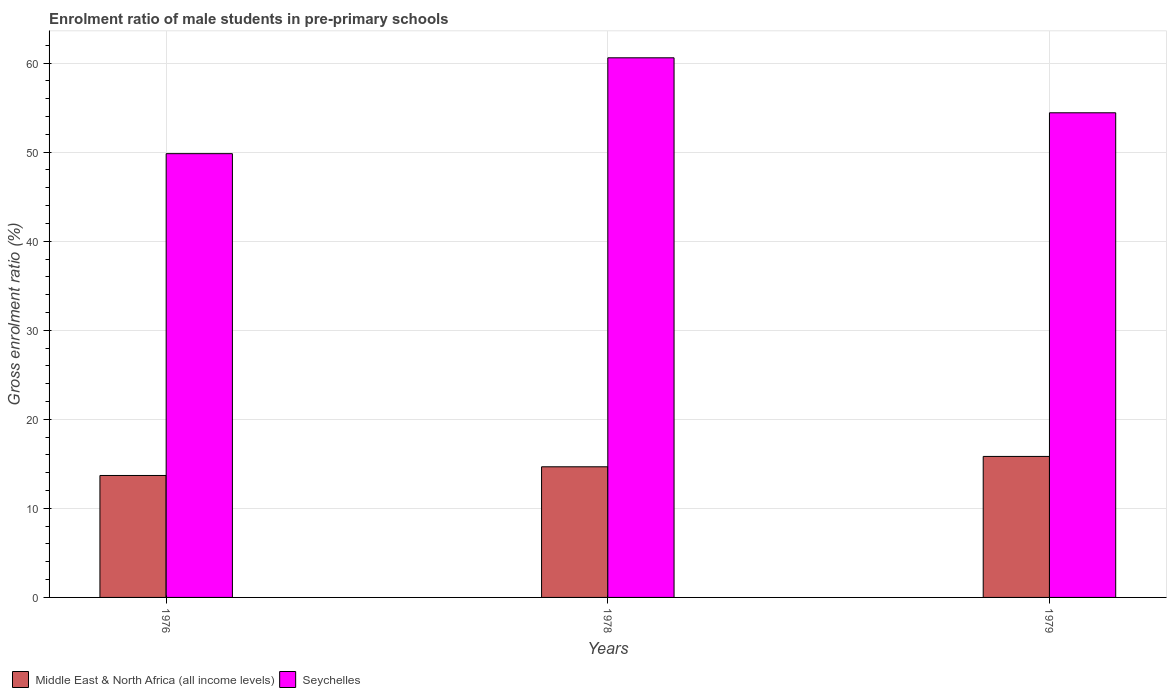How many groups of bars are there?
Your response must be concise. 3. Are the number of bars on each tick of the X-axis equal?
Keep it short and to the point. Yes. What is the label of the 2nd group of bars from the left?
Provide a succinct answer. 1978. In how many cases, is the number of bars for a given year not equal to the number of legend labels?
Your response must be concise. 0. What is the enrolment ratio of male students in pre-primary schools in Middle East & North Africa (all income levels) in 1978?
Offer a terse response. 14.67. Across all years, what is the maximum enrolment ratio of male students in pre-primary schools in Seychelles?
Your response must be concise. 60.59. Across all years, what is the minimum enrolment ratio of male students in pre-primary schools in Middle East & North Africa (all income levels)?
Offer a very short reply. 13.69. In which year was the enrolment ratio of male students in pre-primary schools in Middle East & North Africa (all income levels) maximum?
Make the answer very short. 1979. In which year was the enrolment ratio of male students in pre-primary schools in Seychelles minimum?
Offer a very short reply. 1976. What is the total enrolment ratio of male students in pre-primary schools in Seychelles in the graph?
Provide a succinct answer. 164.84. What is the difference between the enrolment ratio of male students in pre-primary schools in Seychelles in 1976 and that in 1978?
Keep it short and to the point. -10.76. What is the difference between the enrolment ratio of male students in pre-primary schools in Seychelles in 1976 and the enrolment ratio of male students in pre-primary schools in Middle East & North Africa (all income levels) in 1978?
Offer a terse response. 35.16. What is the average enrolment ratio of male students in pre-primary schools in Seychelles per year?
Your answer should be compact. 54.95. In the year 1978, what is the difference between the enrolment ratio of male students in pre-primary schools in Seychelles and enrolment ratio of male students in pre-primary schools in Middle East & North Africa (all income levels)?
Provide a succinct answer. 45.92. What is the ratio of the enrolment ratio of male students in pre-primary schools in Middle East & North Africa (all income levels) in 1978 to that in 1979?
Make the answer very short. 0.93. Is the enrolment ratio of male students in pre-primary schools in Middle East & North Africa (all income levels) in 1976 less than that in 1978?
Make the answer very short. Yes. What is the difference between the highest and the second highest enrolment ratio of male students in pre-primary schools in Middle East & North Africa (all income levels)?
Provide a succinct answer. 1.16. What is the difference between the highest and the lowest enrolment ratio of male students in pre-primary schools in Middle East & North Africa (all income levels)?
Offer a terse response. 2.14. Is the sum of the enrolment ratio of male students in pre-primary schools in Middle East & North Africa (all income levels) in 1978 and 1979 greater than the maximum enrolment ratio of male students in pre-primary schools in Seychelles across all years?
Make the answer very short. No. What does the 2nd bar from the left in 1978 represents?
Offer a terse response. Seychelles. What does the 2nd bar from the right in 1978 represents?
Provide a succinct answer. Middle East & North Africa (all income levels). Does the graph contain any zero values?
Keep it short and to the point. No. Does the graph contain grids?
Your answer should be very brief. Yes. Where does the legend appear in the graph?
Ensure brevity in your answer.  Bottom left. How many legend labels are there?
Provide a short and direct response. 2. How are the legend labels stacked?
Your answer should be compact. Horizontal. What is the title of the graph?
Your response must be concise. Enrolment ratio of male students in pre-primary schools. What is the label or title of the Y-axis?
Provide a succinct answer. Gross enrolment ratio (%). What is the Gross enrolment ratio (%) in Middle East & North Africa (all income levels) in 1976?
Ensure brevity in your answer.  13.69. What is the Gross enrolment ratio (%) in Seychelles in 1976?
Give a very brief answer. 49.83. What is the Gross enrolment ratio (%) of Middle East & North Africa (all income levels) in 1978?
Your response must be concise. 14.67. What is the Gross enrolment ratio (%) of Seychelles in 1978?
Keep it short and to the point. 60.59. What is the Gross enrolment ratio (%) of Middle East & North Africa (all income levels) in 1979?
Keep it short and to the point. 15.83. What is the Gross enrolment ratio (%) of Seychelles in 1979?
Provide a short and direct response. 54.42. Across all years, what is the maximum Gross enrolment ratio (%) in Middle East & North Africa (all income levels)?
Give a very brief answer. 15.83. Across all years, what is the maximum Gross enrolment ratio (%) of Seychelles?
Your response must be concise. 60.59. Across all years, what is the minimum Gross enrolment ratio (%) in Middle East & North Africa (all income levels)?
Provide a succinct answer. 13.69. Across all years, what is the minimum Gross enrolment ratio (%) of Seychelles?
Make the answer very short. 49.83. What is the total Gross enrolment ratio (%) in Middle East & North Africa (all income levels) in the graph?
Your answer should be compact. 44.19. What is the total Gross enrolment ratio (%) in Seychelles in the graph?
Ensure brevity in your answer.  164.84. What is the difference between the Gross enrolment ratio (%) in Middle East & North Africa (all income levels) in 1976 and that in 1978?
Your answer should be very brief. -0.97. What is the difference between the Gross enrolment ratio (%) in Seychelles in 1976 and that in 1978?
Provide a short and direct response. -10.76. What is the difference between the Gross enrolment ratio (%) of Middle East & North Africa (all income levels) in 1976 and that in 1979?
Make the answer very short. -2.14. What is the difference between the Gross enrolment ratio (%) in Seychelles in 1976 and that in 1979?
Provide a short and direct response. -4.59. What is the difference between the Gross enrolment ratio (%) of Middle East & North Africa (all income levels) in 1978 and that in 1979?
Give a very brief answer. -1.16. What is the difference between the Gross enrolment ratio (%) of Seychelles in 1978 and that in 1979?
Keep it short and to the point. 6.17. What is the difference between the Gross enrolment ratio (%) of Middle East & North Africa (all income levels) in 1976 and the Gross enrolment ratio (%) of Seychelles in 1978?
Your answer should be very brief. -46.9. What is the difference between the Gross enrolment ratio (%) in Middle East & North Africa (all income levels) in 1976 and the Gross enrolment ratio (%) in Seychelles in 1979?
Provide a short and direct response. -40.73. What is the difference between the Gross enrolment ratio (%) in Middle East & North Africa (all income levels) in 1978 and the Gross enrolment ratio (%) in Seychelles in 1979?
Your response must be concise. -39.75. What is the average Gross enrolment ratio (%) of Middle East & North Africa (all income levels) per year?
Ensure brevity in your answer.  14.73. What is the average Gross enrolment ratio (%) of Seychelles per year?
Your answer should be compact. 54.95. In the year 1976, what is the difference between the Gross enrolment ratio (%) in Middle East & North Africa (all income levels) and Gross enrolment ratio (%) in Seychelles?
Keep it short and to the point. -36.14. In the year 1978, what is the difference between the Gross enrolment ratio (%) in Middle East & North Africa (all income levels) and Gross enrolment ratio (%) in Seychelles?
Offer a terse response. -45.92. In the year 1979, what is the difference between the Gross enrolment ratio (%) of Middle East & North Africa (all income levels) and Gross enrolment ratio (%) of Seychelles?
Your answer should be very brief. -38.59. What is the ratio of the Gross enrolment ratio (%) in Middle East & North Africa (all income levels) in 1976 to that in 1978?
Ensure brevity in your answer.  0.93. What is the ratio of the Gross enrolment ratio (%) of Seychelles in 1976 to that in 1978?
Make the answer very short. 0.82. What is the ratio of the Gross enrolment ratio (%) of Middle East & North Africa (all income levels) in 1976 to that in 1979?
Give a very brief answer. 0.86. What is the ratio of the Gross enrolment ratio (%) in Seychelles in 1976 to that in 1979?
Offer a very short reply. 0.92. What is the ratio of the Gross enrolment ratio (%) of Middle East & North Africa (all income levels) in 1978 to that in 1979?
Your response must be concise. 0.93. What is the ratio of the Gross enrolment ratio (%) of Seychelles in 1978 to that in 1979?
Make the answer very short. 1.11. What is the difference between the highest and the second highest Gross enrolment ratio (%) in Middle East & North Africa (all income levels)?
Ensure brevity in your answer.  1.16. What is the difference between the highest and the second highest Gross enrolment ratio (%) in Seychelles?
Give a very brief answer. 6.17. What is the difference between the highest and the lowest Gross enrolment ratio (%) in Middle East & North Africa (all income levels)?
Make the answer very short. 2.14. What is the difference between the highest and the lowest Gross enrolment ratio (%) of Seychelles?
Offer a terse response. 10.76. 